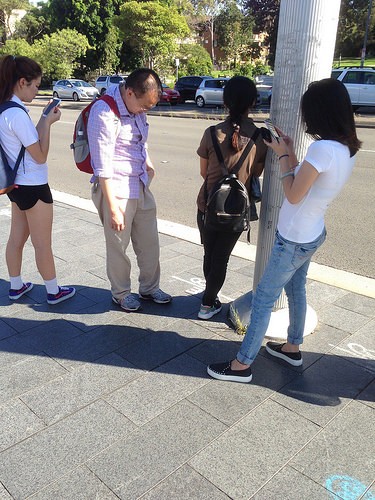<image>
Can you confirm if the bag is on the girl? Yes. Looking at the image, I can see the bag is positioned on top of the girl, with the girl providing support. Is the car on the road? Yes. Looking at the image, I can see the car is positioned on top of the road, with the road providing support. 